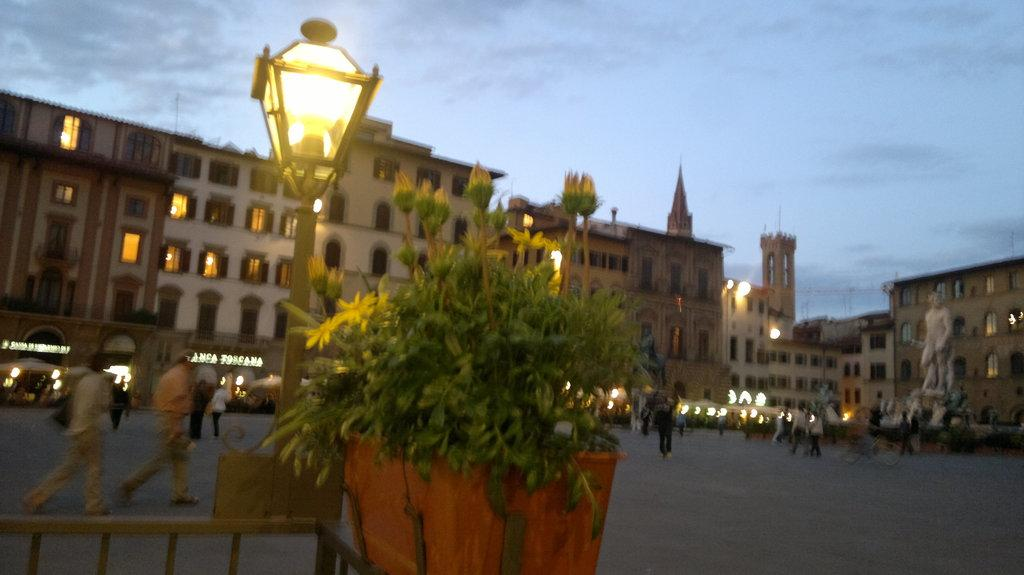How many people are in the group in the image? There is a group of people in the image, but the exact number is not specified. What are some of the people in the group doing? Some people in the group are standing, and some are walking. What other objects or features can be seen in the image? There is a plant, a statue, lights, and buildings in the image. What type of ring can be seen on the statue's finger in the image? There is no ring visible on the statue's finger in the image. What scientific discovery is being celebrated in the image? There is no indication of a scientific discovery being celebrated in the image. 